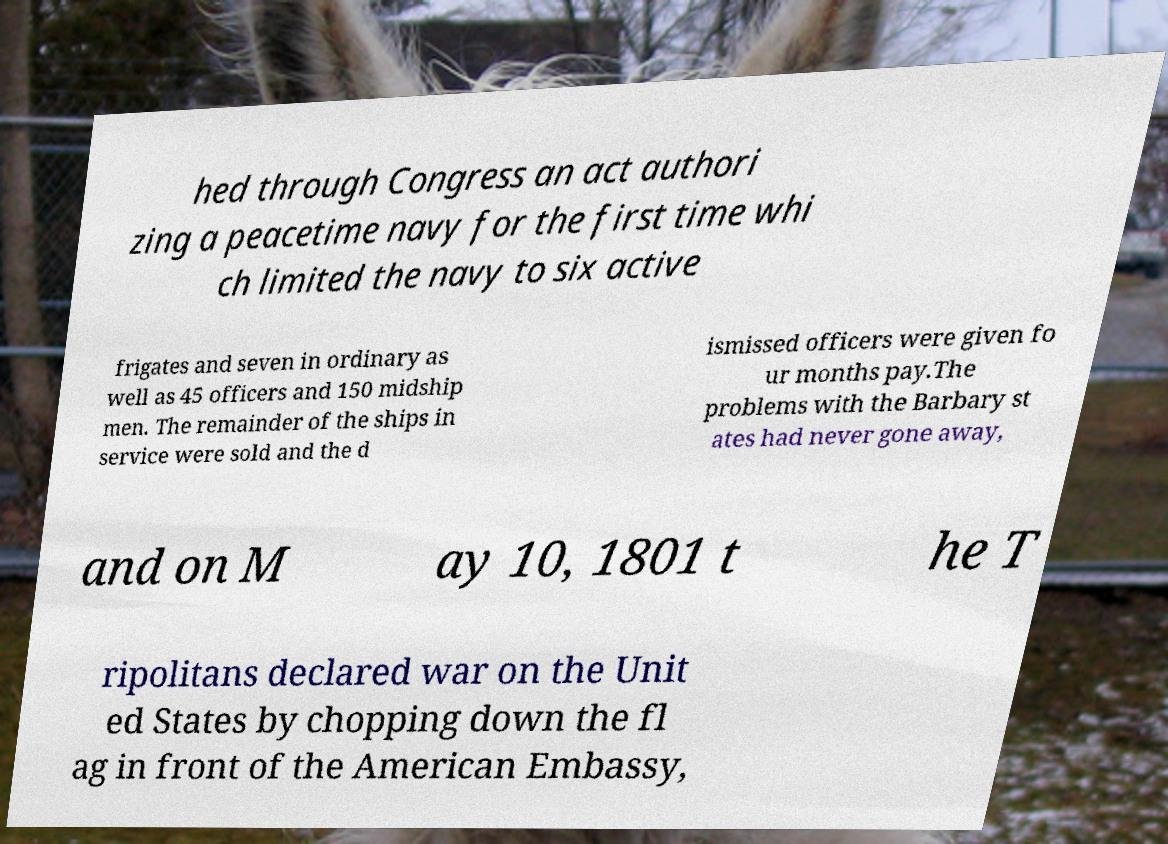Can you read and provide the text displayed in the image?This photo seems to have some interesting text. Can you extract and type it out for me? hed through Congress an act authori zing a peacetime navy for the first time whi ch limited the navy to six active frigates and seven in ordinary as well as 45 officers and 150 midship men. The remainder of the ships in service were sold and the d ismissed officers were given fo ur months pay.The problems with the Barbary st ates had never gone away, and on M ay 10, 1801 t he T ripolitans declared war on the Unit ed States by chopping down the fl ag in front of the American Embassy, 